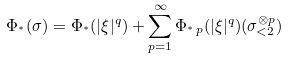Convert formula to latex. <formula><loc_0><loc_0><loc_500><loc_500>\Phi _ { ^ { * } } ( \sigma ) = \Phi _ { ^ { * } } ( | \xi | ^ { q } ) + \sum _ { p = 1 } ^ { \infty } \Phi _ { ^ { * } \, p } ( | \xi | ^ { q } ) ( \sigma _ { < 2 } ^ { \otimes p } )</formula> 